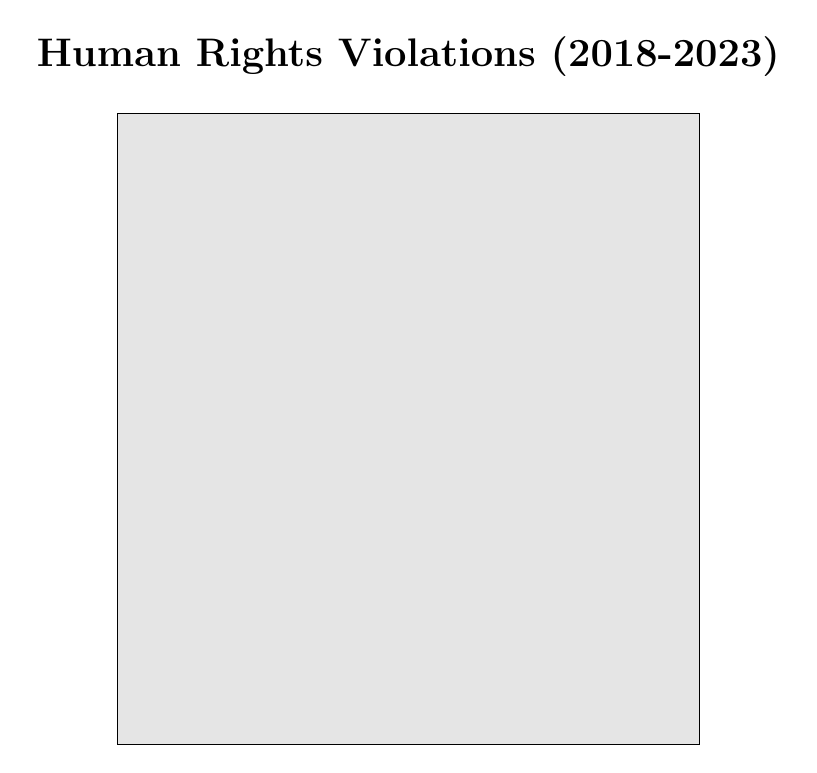What is the total number of human rights violations reported in sanctioned countries? The data lists five countries classified as sanctioned, with their human rights violations being 1200, 800, 950, 600, and 700. We sum these values: 1200 + 800 + 950 + 600 + 700 = 4250.
Answer: 4250 What is the total number of human rights violations reported in non-sanctioned countries? There are five non-sanctioned countries with reported violations of 900, 950, 750, 600, and 500. Summing these gives: 900 + 950 + 750 + 600 + 500 = 3750.
Answer: 3750 Which sanctioned country has the highest number of human rights violations? Looking at the values for sanctioned countries, North Korea has the highest reported violations with 1200, compared to others like Iran (800) and Syria (950).
Answer: North Korea Is the number of human rights violations in Saudi Arabia higher than in any sanctioned country? Saudi Arabia has 900 violations, which is higher than Venezuela (600) and Russia (700) but lower than North Korea (1200), Iran (800), and Syria (950). Hence, the statement is false.
Answer: No What is the average number of human rights violations in sanctioned countries? To find the average, sum the violations (4250) from sanctioned countries and divide by the number of these countries (5): 4250 / 5 = 850.
Answer: 850 Are there more total human rights violations in sanctioned or non-sanctioned countries? The total in sanctioned countries is 4250, while in non-sanctioned countries it’s 3750. Since 4250 is greater than 3750, we conclude that sanctioned countries have more violations.
Answer: Sanctioned What is the median number of human rights violations reported for non-sanctioned countries? The violations for non-sanctioned countries are 500, 600, 750, 900, and 950. Arranging these in order gives: 500, 600, 750, 900, 950. The median is the middle value, which is 750.
Answer: 750 How many more violations are reported in North Korea compared to the United States? North Korea has 1200 violations while the United States has 500. The difference is 1200 - 500 = 700.
Answer: 700 Are the human rights violations in China greater than those in Turkey? China has 950 violations, and Turkey has 600. Since 950 is greater than 600, the answer is yes.
Answer: Yes If we classify countries with over 800 violations, how many are sanctioned? The sanctioned countries with violations above 800 are North Korea (1200), Syria (950), and Iran (800). Therefore, there are three sanctioned countries that meet this criterion.
Answer: 3 